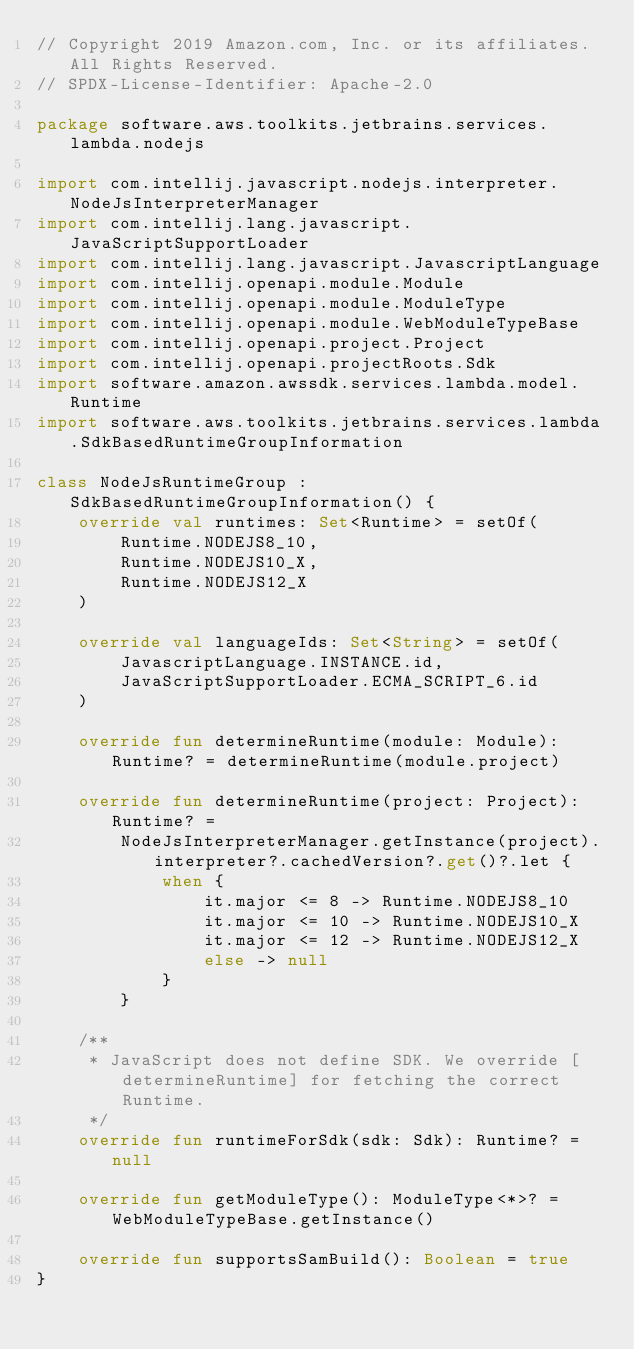Convert code to text. <code><loc_0><loc_0><loc_500><loc_500><_Kotlin_>// Copyright 2019 Amazon.com, Inc. or its affiliates. All Rights Reserved.
// SPDX-License-Identifier: Apache-2.0

package software.aws.toolkits.jetbrains.services.lambda.nodejs

import com.intellij.javascript.nodejs.interpreter.NodeJsInterpreterManager
import com.intellij.lang.javascript.JavaScriptSupportLoader
import com.intellij.lang.javascript.JavascriptLanguage
import com.intellij.openapi.module.Module
import com.intellij.openapi.module.ModuleType
import com.intellij.openapi.module.WebModuleTypeBase
import com.intellij.openapi.project.Project
import com.intellij.openapi.projectRoots.Sdk
import software.amazon.awssdk.services.lambda.model.Runtime
import software.aws.toolkits.jetbrains.services.lambda.SdkBasedRuntimeGroupInformation

class NodeJsRuntimeGroup : SdkBasedRuntimeGroupInformation() {
    override val runtimes: Set<Runtime> = setOf(
        Runtime.NODEJS8_10,
        Runtime.NODEJS10_X,
        Runtime.NODEJS12_X
    )

    override val languageIds: Set<String> = setOf(
        JavascriptLanguage.INSTANCE.id,
        JavaScriptSupportLoader.ECMA_SCRIPT_6.id
    )

    override fun determineRuntime(module: Module): Runtime? = determineRuntime(module.project)

    override fun determineRuntime(project: Project): Runtime? =
        NodeJsInterpreterManager.getInstance(project).interpreter?.cachedVersion?.get()?.let {
            when {
                it.major <= 8 -> Runtime.NODEJS8_10
                it.major <= 10 -> Runtime.NODEJS10_X
                it.major <= 12 -> Runtime.NODEJS12_X
                else -> null
            }
        }

    /**
     * JavaScript does not define SDK. We override [determineRuntime] for fetching the correct Runtime.
     */
    override fun runtimeForSdk(sdk: Sdk): Runtime? = null

    override fun getModuleType(): ModuleType<*>? = WebModuleTypeBase.getInstance()

    override fun supportsSamBuild(): Boolean = true
}
</code> 